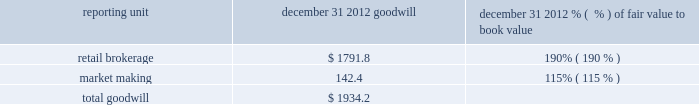There is no goodwill assigned to reporting units within the balance sheet management segment .
The table shows the amount of goodwill allocated to each of the reporting units and the fair value as a percentage of book value for the reporting units in the trading and investing segment ( dollars in millions ) : .
We also evaluate the remaining useful lives on intangible assets each reporting period to determine whether events and circumstances warrant a revision to the remaining period of amortization .
Other intangible assets have a weighted average remaining useful life of 13 years .
We did not recognize impairment on our other intangible assets in the periods presented .
Effects if actual results differ if our estimates of fair value for the reporting units change due to changes in our business or other factors , we may determine that an impairment charge is necessary .
Estimates of fair value are determined based on a complex model using estimated future cash flows and company comparisons .
If actual cash flows are less than estimated future cash flows used in the annual assessment , then goodwill would have to be tested for impairment .
The estimated fair value of the market making reporting unit as a percentage of book value was approximately 115% ( 115 % ) ; therefore , if actual cash flows are less than our estimated cash flows , goodwill impairment could occur in the market making reporting unit in the future .
These cash flows will be monitored closely to determine if a further evaluation of potential impairment is necessary so that impairment could be recognized in a timely manner .
In addition , following the review of order handling practices and pricing for order flow between e*trade securities llc and gi execution services , llc , our regulators may initiate investigations into our historical practices which could subject us to monetary penalties and cease-and-desist orders , which could also prompt claims by customers of e*trade securities llc .
Any of these actions could materially and adversely affect our market making and trade execution businesses , which could impact future cash flows and could result in goodwill impairment .
Intangible assets are amortized over their estimated useful lives .
If changes in the estimated underlying revenue occur , impairment or a change in the remaining life may need to be recognized .
Estimates of effective tax rates , deferred taxes and valuation allowance description in preparing the consolidated financial statements , we calculate income tax expense ( benefit ) based on our interpretation of the tax laws in the various jurisdictions where we conduct business .
This requires us to estimate current tax obligations and the realizability of uncertain tax positions and to assess temporary differences between the financial statement carrying amounts and the tax basis of assets and liabilities .
These differences result in deferred tax assets and liabilities , the net amount of which we show as other assets or other liabilities on the consolidated balance sheet .
We must also assess the likelihood that each of the deferred tax assets will be realized .
To the extent we believe that realization is not more likely than not , we establish a valuation allowance .
When we establish a valuation allowance or increase this allowance in a reporting period , we generally record a corresponding tax expense in the consolidated statement of income ( loss ) .
Conversely , to the extent circumstances indicate that a valuation allowance is no longer necessary , that portion of the valuation allowance is reversed , which generally reduces overall income tax expense .
At december 31 , 2012 we had net deferred tax assets of $ 1416.2 million , net of a valuation allowance ( on state , foreign country and charitable contribution deferred tax assets ) of $ 97.8 million. .
What percentage of total goodwill is comprised of market making at december 31 2012? 
Computations: (142.4 / 1934.2)
Answer: 0.07362. 